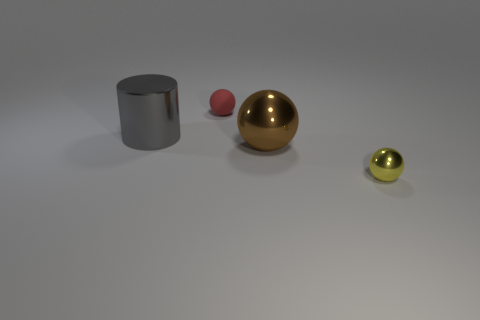Subtract all shiny spheres. How many spheres are left? 1 Add 3 red rubber balls. How many objects exist? 7 Subtract all spheres. How many objects are left? 1 Subtract all green balls. Subtract all purple cylinders. How many balls are left? 3 Add 4 purple balls. How many purple balls exist? 4 Subtract 1 gray cylinders. How many objects are left? 3 Subtract all big matte cylinders. Subtract all small yellow shiny objects. How many objects are left? 3 Add 4 big cylinders. How many big cylinders are left? 5 